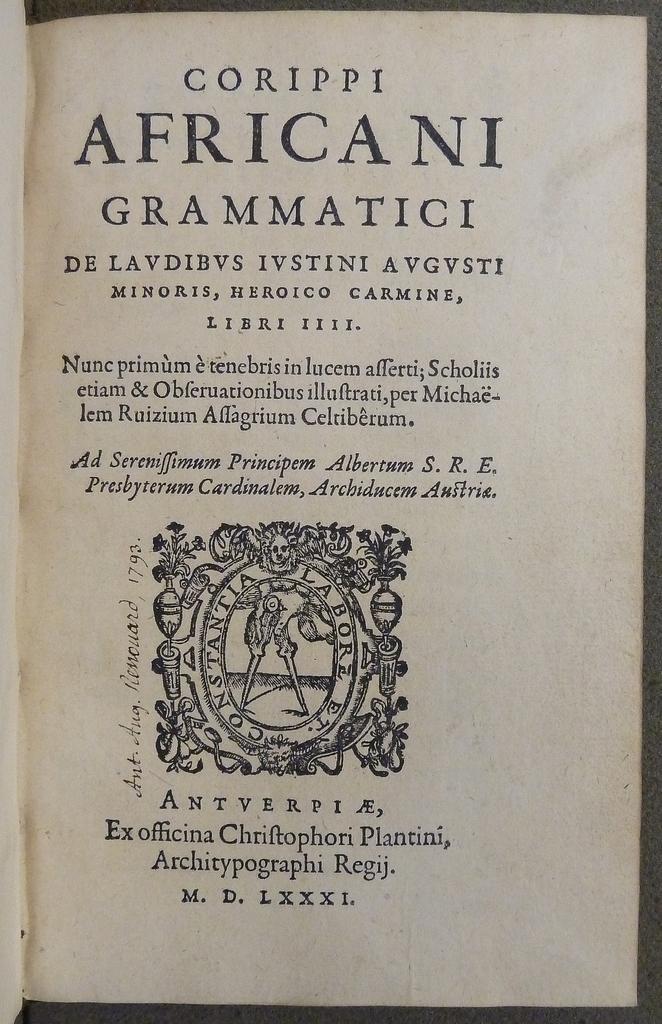<image>
Relay a brief, clear account of the picture shown. A book page opened to the page with the words Corippi African Grammatici at the top. 